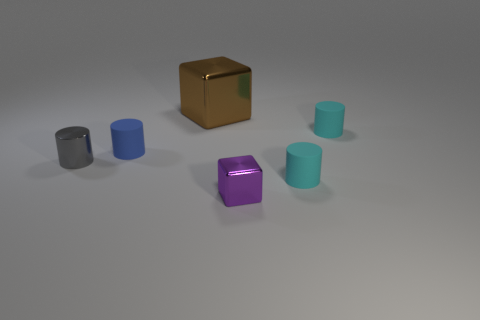There is a small matte object that is in front of the metallic cylinder; is it the same color as the small rubber cylinder that is behind the tiny blue matte cylinder?
Ensure brevity in your answer.  Yes. There is a brown metallic thing that is behind the tiny cylinder that is in front of the gray metal object; what size is it?
Keep it short and to the point. Large. Are there more blue cylinders than cyan things?
Provide a short and direct response. No. Do the matte cylinder left of the purple shiny block and the brown cube have the same size?
Keep it short and to the point. No. Is the shape of the gray object the same as the tiny blue matte object?
Provide a short and direct response. Yes. Is there any other thing that has the same size as the gray shiny object?
Offer a terse response. Yes. There is a blue rubber thing that is the same shape as the small gray thing; what is its size?
Keep it short and to the point. Small. Is the number of big brown metal objects behind the purple shiny block greater than the number of brown metal things to the left of the blue matte object?
Provide a short and direct response. Yes. Do the gray thing and the cube in front of the small blue cylinder have the same material?
Offer a very short reply. Yes. Is there anything else that is the same shape as the small blue matte thing?
Your answer should be compact. Yes. 